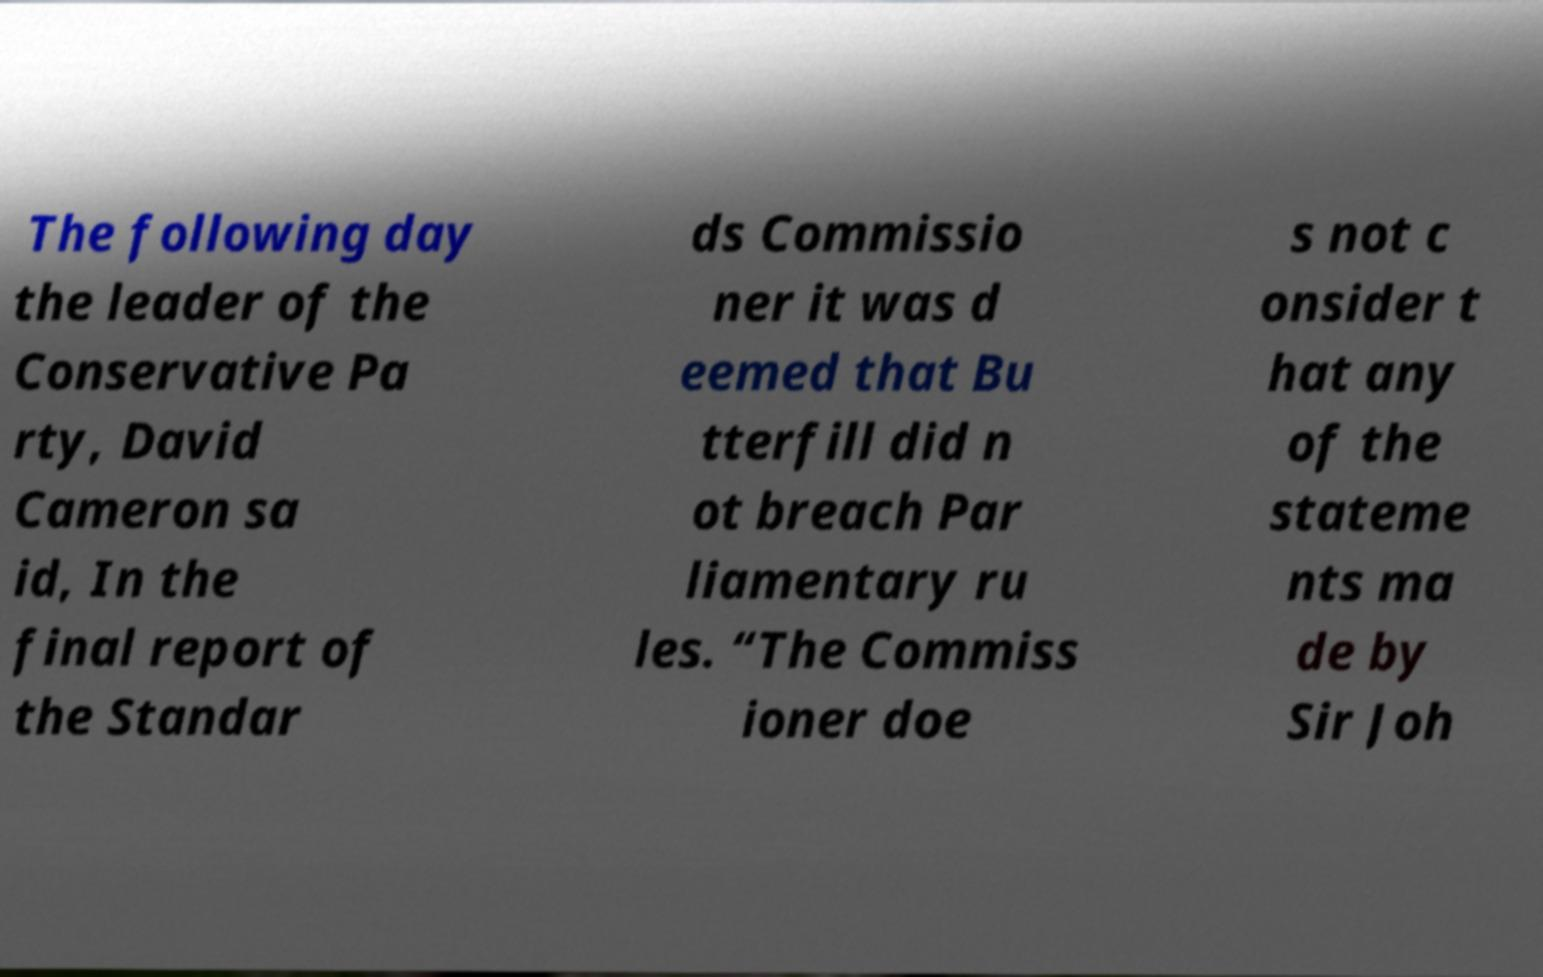Please read and relay the text visible in this image. What does it say? The following day the leader of the Conservative Pa rty, David Cameron sa id, In the final report of the Standar ds Commissio ner it was d eemed that Bu tterfill did n ot breach Par liamentary ru les. “The Commiss ioner doe s not c onsider t hat any of the stateme nts ma de by Sir Joh 